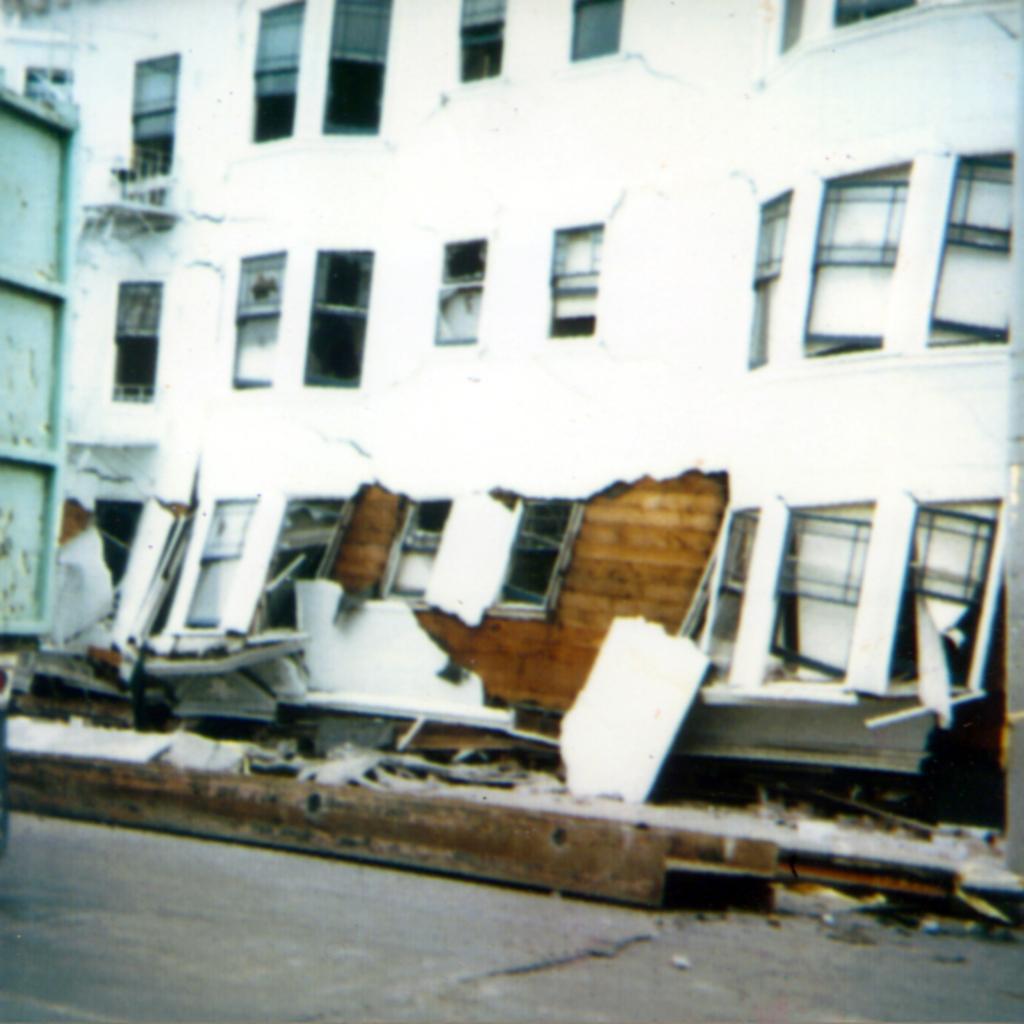Please provide a concise description of this image. This image is taken outdoors. At the bottom of the image there is a road. In the middle of the image there is a collapsed building with walls and windows. There are a few iron bars on the road. On the left side of the image there is a vehicle. 